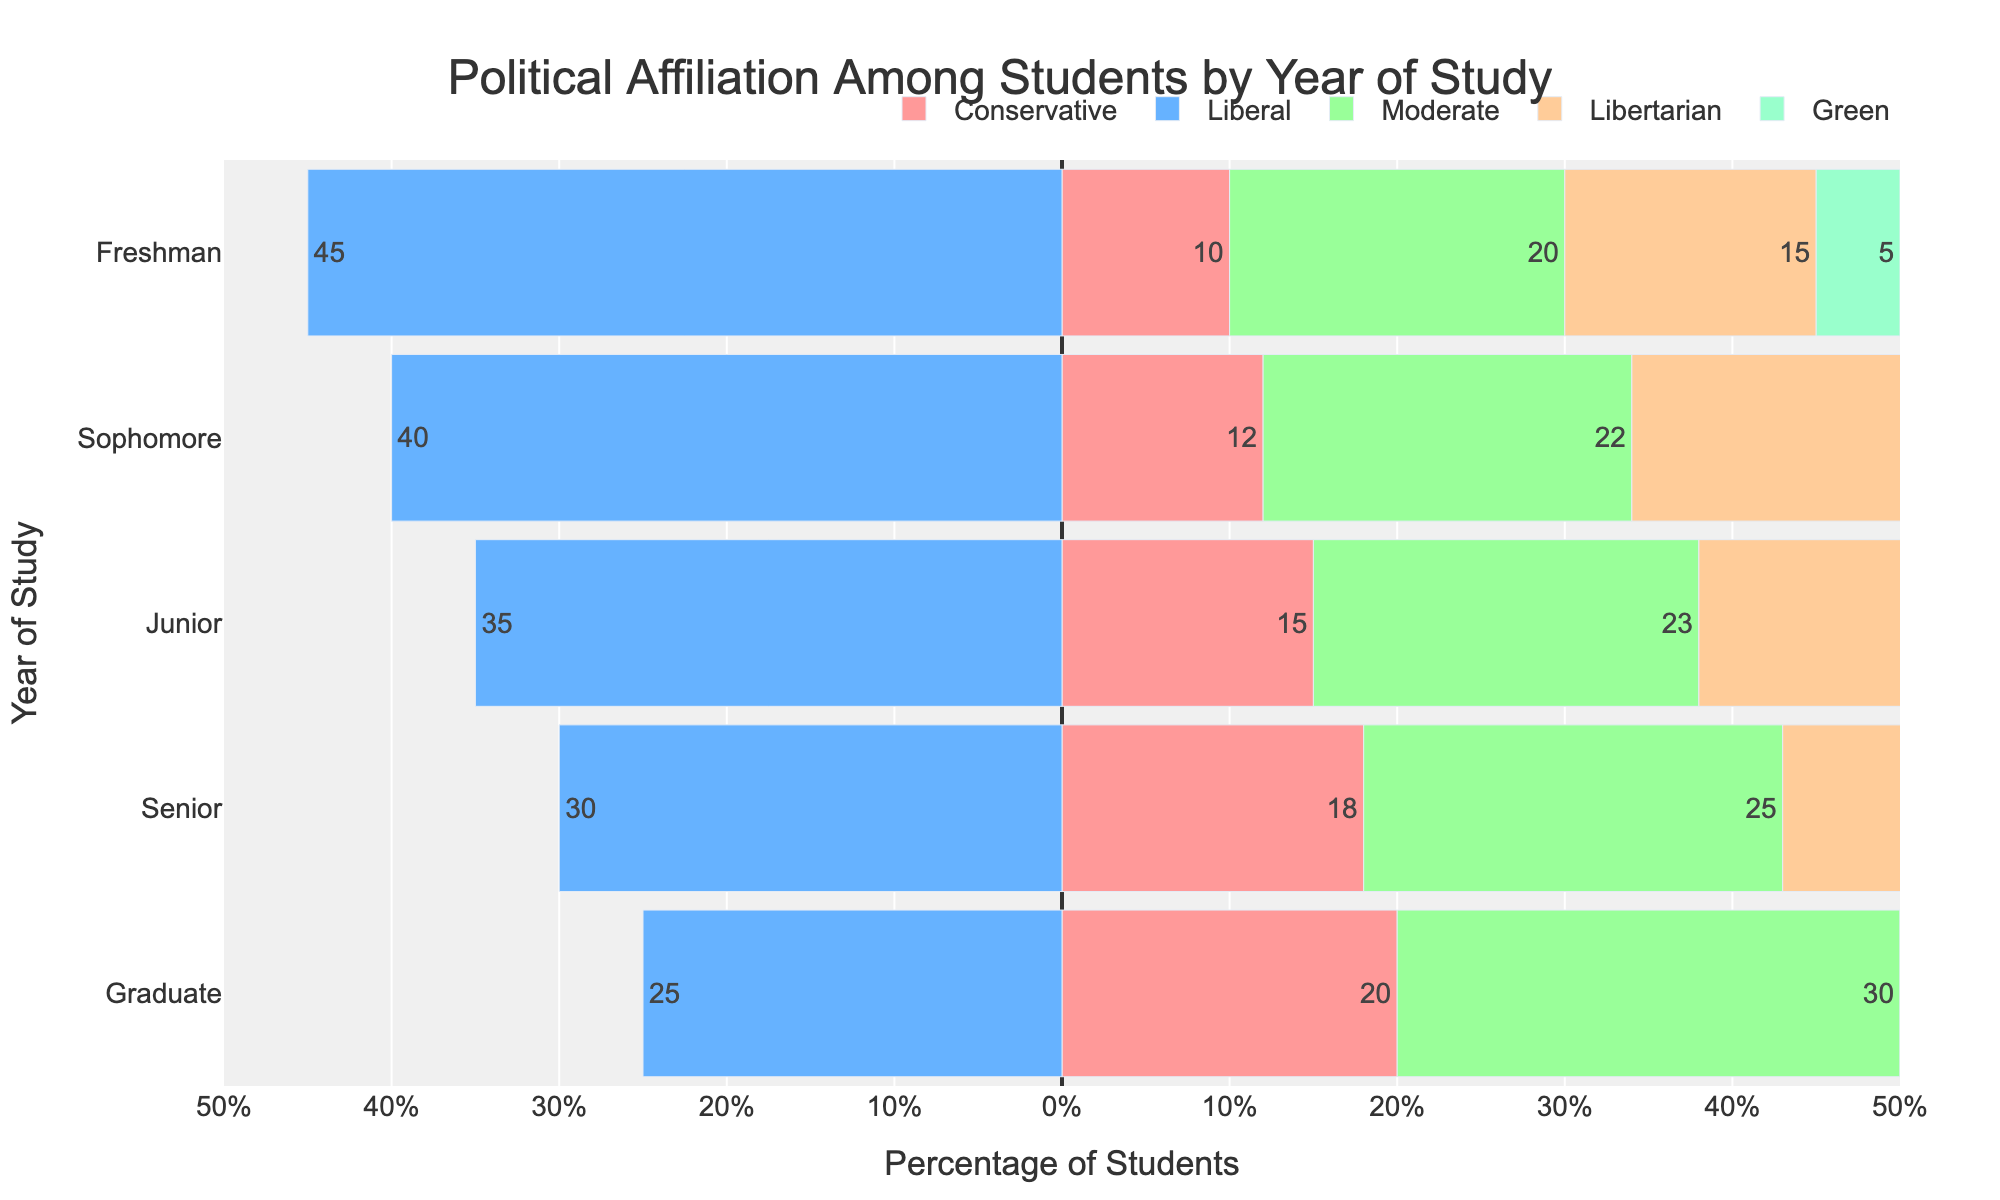How does the percentage of Liberal students change from Freshman to Graduate year? The percentages of Liberal students from Freshman to Graduate years are: 45% (Freshman), 40% (Sophomore), 35% (Junior), 30% (Senior), and 25% (Graduate). We see a steady decline in the percentage as the year of study progresses.
Answer: Declines Which political affiliation has the highest percentage among Freshmen? By comparing the values of each affinity among Freshmen, we see that Liberal students have the highest percentage at 45%.
Answer: Liberal What is the difference between the percentage of Conservative and Liberal students in Graduate year? The percentage of Conservative students in the Graduate year is 20% and that of Liberal students is 25%. The difference is 25% - 20% = 5%.
Answer: 5% How many groups have a percentage of at least 20% among Juniors? Examining the percentages for Juniors: Conservative (15%), Liberal (35%), Moderate (23%), Libertarian (18%), and Green (9%). The groups with at least 20% are Liberal (35%) and Moderate (23%), so there are 2 groups.
Answer: 2 Which political affiliation has the least number of students for Senior year, and what percentage do they represent? Among Seniors, the percentages for each group are as follows: Conservative (18%), Liberal (30%), Moderate (25%), Libertarian (17%), and Green (10%). The Green party has the least percentage with 10%.
Answer: Green, 10% Is the number of Moderate students higher in Sophomore or Junior year? The percentage of Moderate students is 22% in Sophomore year and 23% in Junior year. Since 23% is higher than 22%, there are more Moderate students in the Junior year.
Answer: Junior What is the approximate combined percentage of Libertarian and Green students in the Senior year? The percentage of Libertarian students in the Senior year is 17% and that of Green students is 10%. The combined percentage is 17% + 10% = 27%.
Answer: 27% How many political affiliations have a higher percentage in Freshman year compared to Graduate year? Comparing the Freshman and Graduate years: Conservative (10% vs. 20%), Liberal (45% vs. 25%), Moderate (20% vs. 30%), Libertarian (15% vs. 15%), Green (5% vs. 10%). Only Liberal students have a higher percentage in Freshman year (45%) compared to Graduate year (25%).
Answer: 1 Which year of study has the most balanced distribution of political affiliations? By visually inspecting where no single political affiliation vastly dominates: Freshman (most as Liberal), Sophomore (most as Liberal), Junior (most as Liberal), Senior (more balanced but Liberal still dominates), Graduate (more balanced). Graduate year seems more balanced without a single dominant affiliation.
Answer: Graduate 